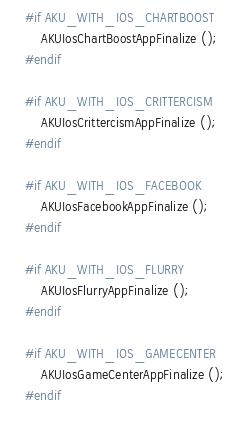Convert code to text. <code><loc_0><loc_0><loc_500><loc_500><_ObjectiveC_>
	#if AKU_WITH_IOS_CHARTBOOST
		AKUIosChartBoostAppFinalize ();
	#endif

	#if AKU_WITH_IOS_CRITTERCISM
		AKUIosCrittercismAppFinalize ();
	#endif

	#if AKU_WITH_IOS_FACEBOOK
		AKUIosFacebookAppFinalize ();
	#endif
	
	#if AKU_WITH_IOS_FLURRY
		AKUIosFlurryAppFinalize ();
	#endif

	#if AKU_WITH_IOS_GAMECENTER
		AKUIosGameCenterAppFinalize ();
	#endif
	</code> 